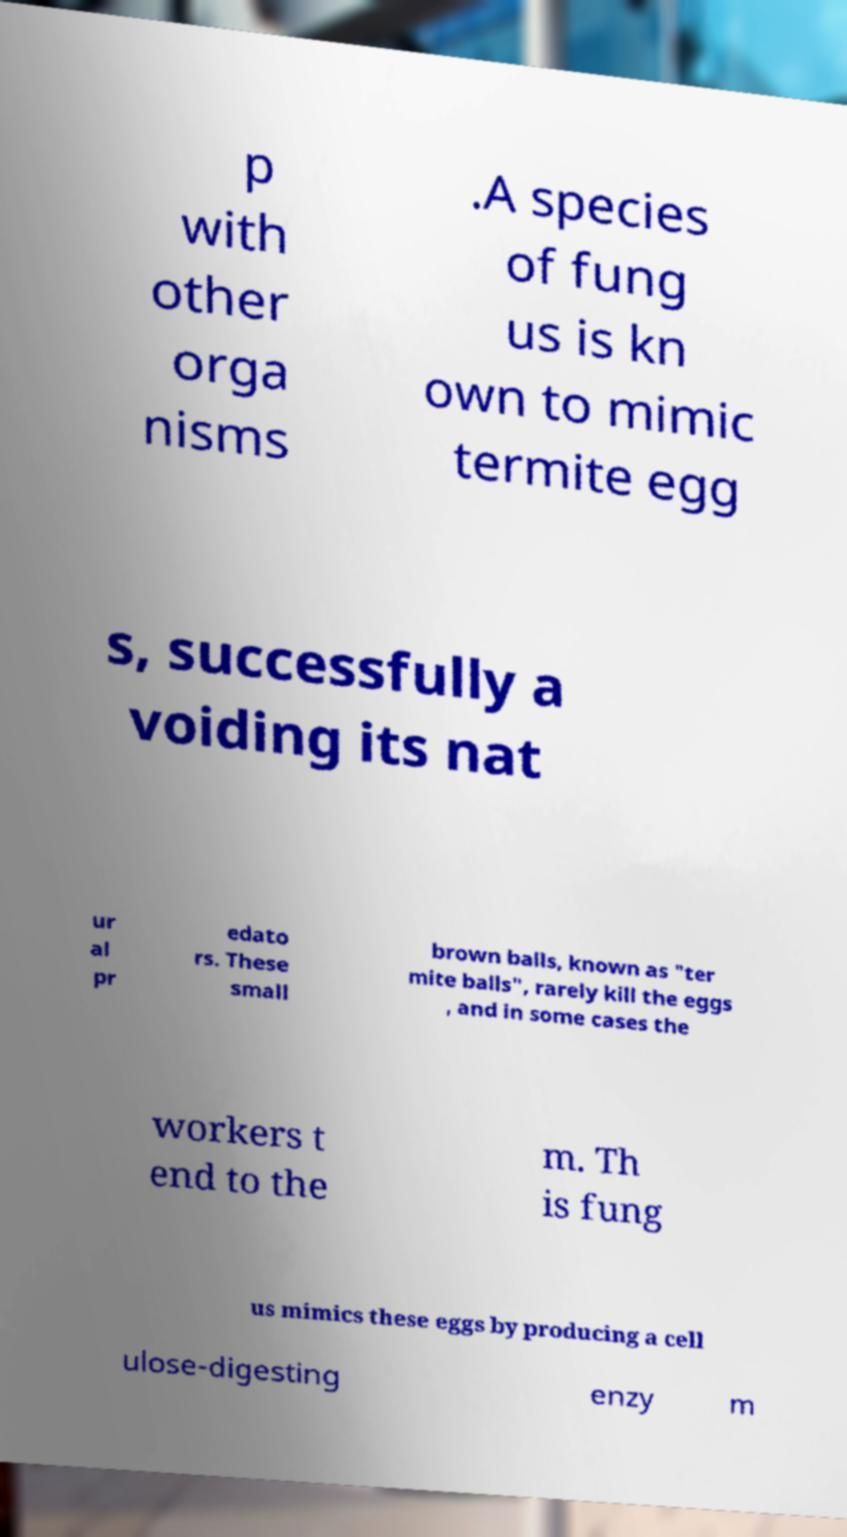For documentation purposes, I need the text within this image transcribed. Could you provide that? p with other orga nisms .A species of fung us is kn own to mimic termite egg s, successfully a voiding its nat ur al pr edato rs. These small brown balls, known as "ter mite balls", rarely kill the eggs , and in some cases the workers t end to the m. Th is fung us mimics these eggs by producing a cell ulose-digesting enzy m 